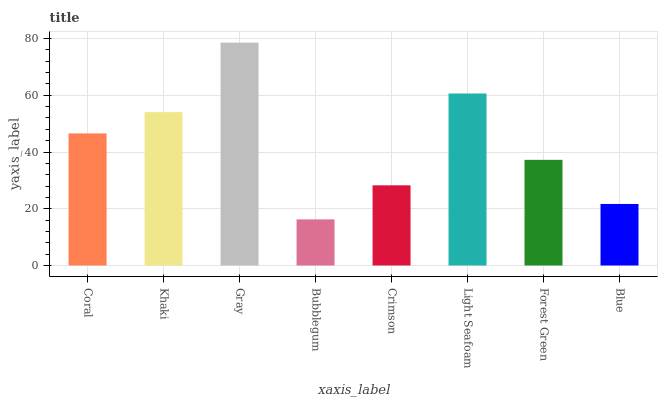Is Khaki the minimum?
Answer yes or no. No. Is Khaki the maximum?
Answer yes or no. No. Is Khaki greater than Coral?
Answer yes or no. Yes. Is Coral less than Khaki?
Answer yes or no. Yes. Is Coral greater than Khaki?
Answer yes or no. No. Is Khaki less than Coral?
Answer yes or no. No. Is Coral the high median?
Answer yes or no. Yes. Is Forest Green the low median?
Answer yes or no. Yes. Is Forest Green the high median?
Answer yes or no. No. Is Coral the low median?
Answer yes or no. No. 